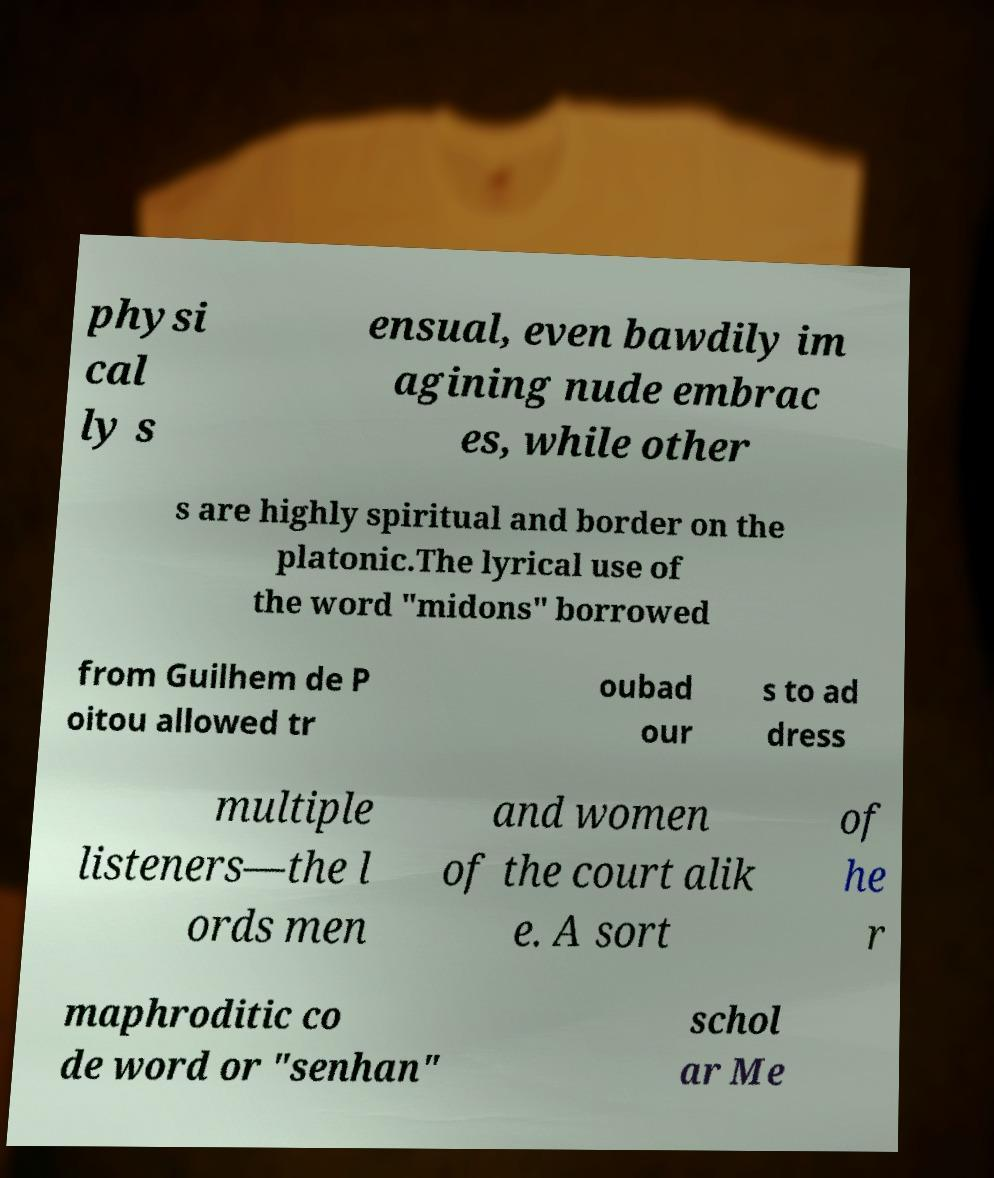For documentation purposes, I need the text within this image transcribed. Could you provide that? physi cal ly s ensual, even bawdily im agining nude embrac es, while other s are highly spiritual and border on the platonic.The lyrical use of the word "midons" borrowed from Guilhem de P oitou allowed tr oubad our s to ad dress multiple listeners—the l ords men and women of the court alik e. A sort of he r maphroditic co de word or "senhan" schol ar Me 